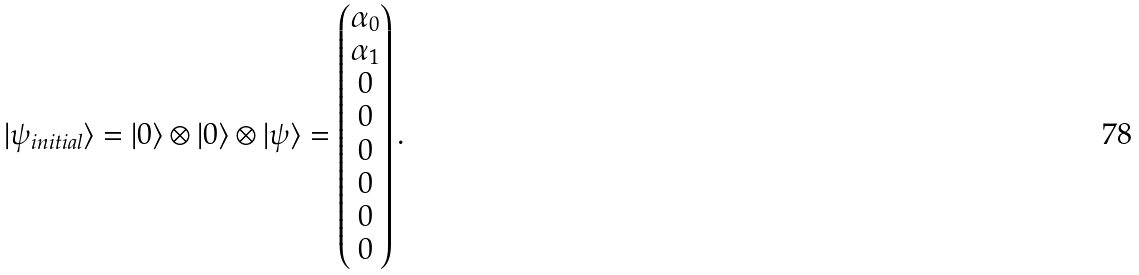<formula> <loc_0><loc_0><loc_500><loc_500>| \psi _ { i n i t i a l } \rangle = | 0 \rangle \otimes | 0 \rangle \otimes | \psi \rangle = \left ( \begin{matrix} \alpha _ { 0 } \\ \alpha _ { 1 } \\ 0 \\ 0 \\ 0 \\ 0 \\ 0 \\ 0 \end{matrix} \right ) .</formula> 